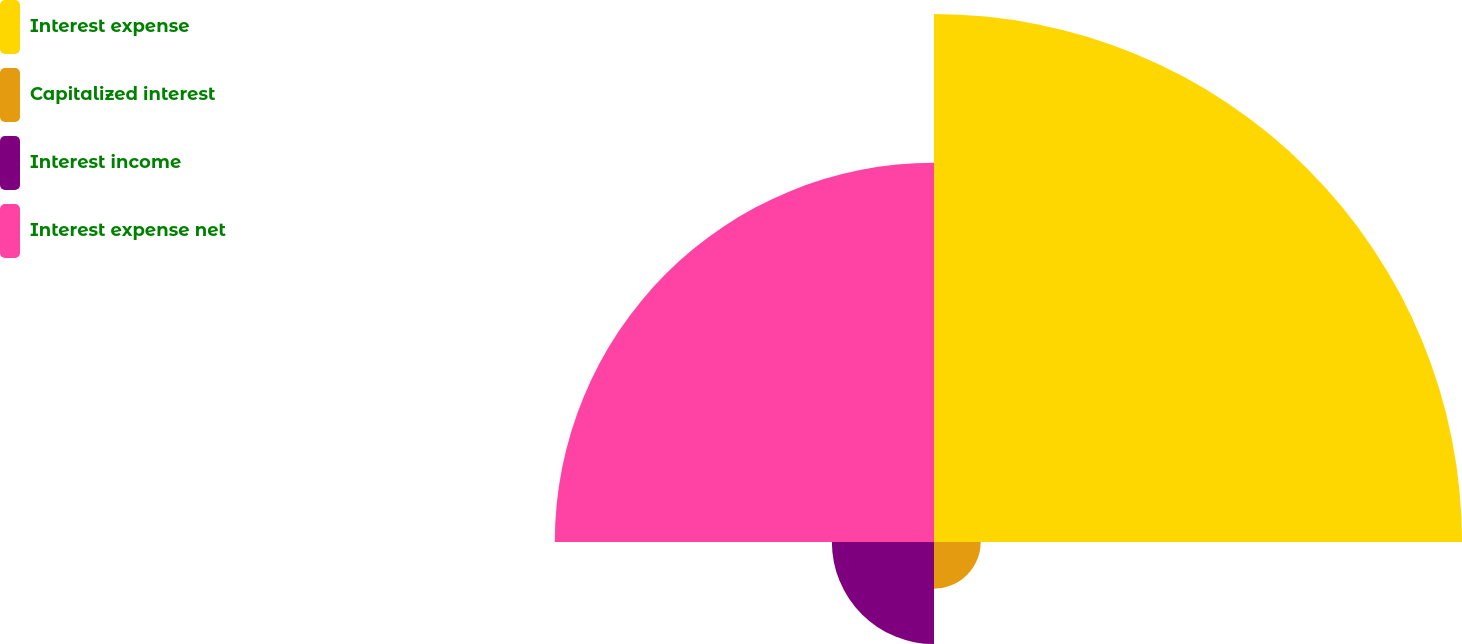Convert chart to OTSL. <chart><loc_0><loc_0><loc_500><loc_500><pie_chart><fcel>Interest expense<fcel>Capitalized interest<fcel>Interest income<fcel>Interest expense net<nl><fcel>50.0%<fcel>4.42%<fcel>9.67%<fcel>35.91%<nl></chart> 